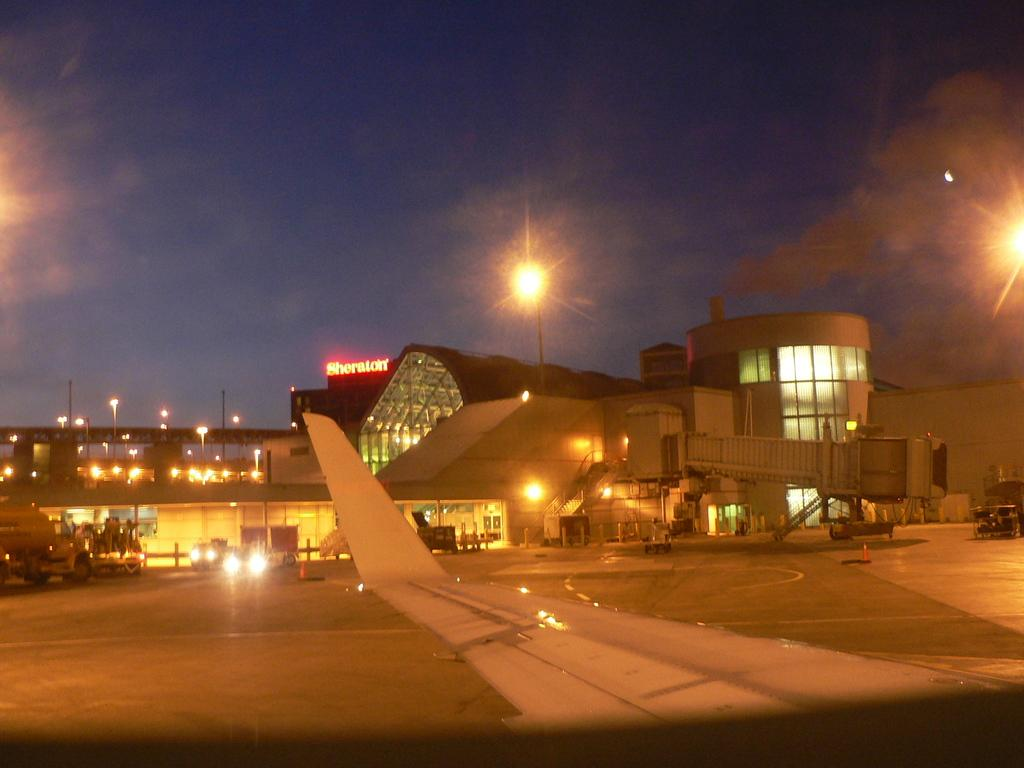What is the perspective of the image? The image is taken from an airplane. What can be seen in the center of the image? There are lights, vehicles, buildings, and other objects in the center of the image. What time of day is the image taken? The image is clicked during night time. What song is being sung by the students in the school in the image? There is no school or students present in the image, and therefore no singing can be observed. 